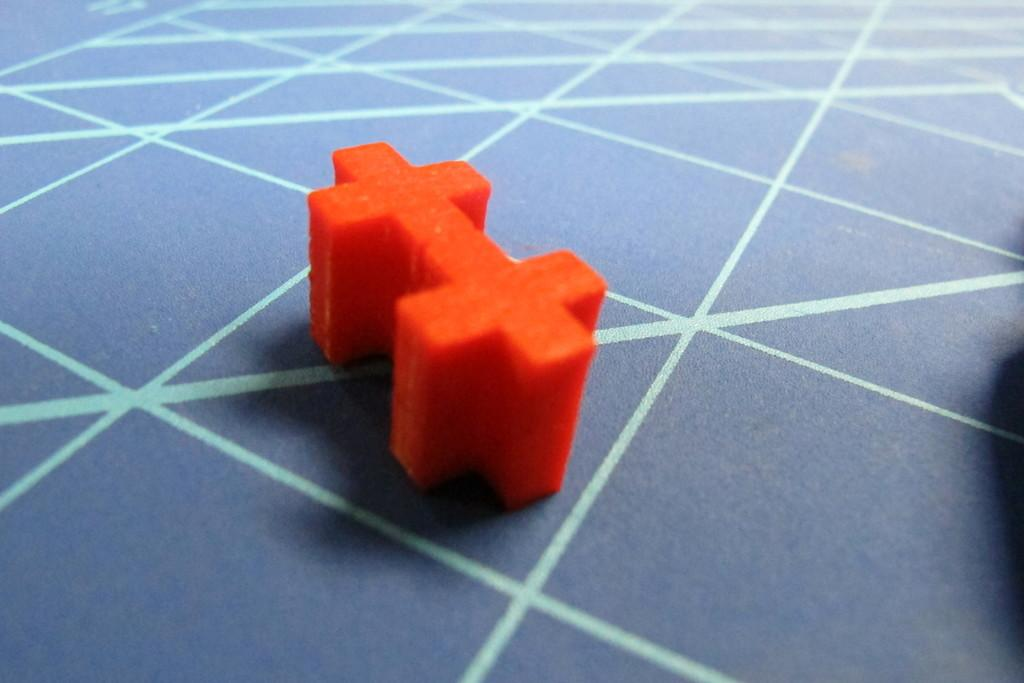What color is the floor in the image? The floor in the image is blue. Can you describe any objects on the floor? There is an orange-colored plus symbol object on the floor. What type of discovery was made in the throat of the person in the image? There is no person or throat present in the image, so it is not possible to answer that question. 